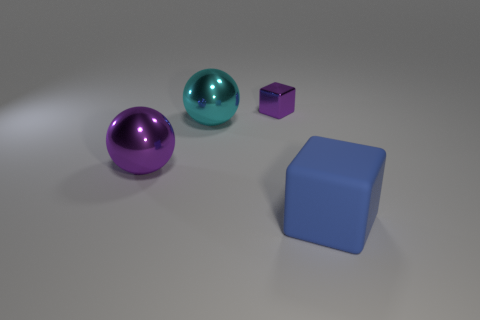Is the shiny block the same size as the blue block?
Your answer should be compact. No. How big is the blue thing?
Your answer should be compact. Large. There is a cyan shiny object; is it the same size as the purple object right of the cyan shiny thing?
Make the answer very short. No. What is the size of the object in front of the purple shiny thing that is to the left of the purple shiny cube that is behind the large purple shiny thing?
Make the answer very short. Large. There is a blue thing that is in front of the big purple metal sphere; what size is it?
Provide a short and direct response. Large. Does the large object right of the tiny purple thing have the same shape as the purple object that is behind the large cyan thing?
Your answer should be compact. Yes. What is the shape of the purple metallic object that is the same size as the cyan sphere?
Your response must be concise. Sphere. How many rubber objects are either large green cylinders or big cyan things?
Your answer should be compact. 0. Is the material of the block to the left of the large cube the same as the thing that is to the right of the small purple cube?
Your response must be concise. No. There is another big object that is the same material as the cyan thing; what color is it?
Give a very brief answer. Purple. 